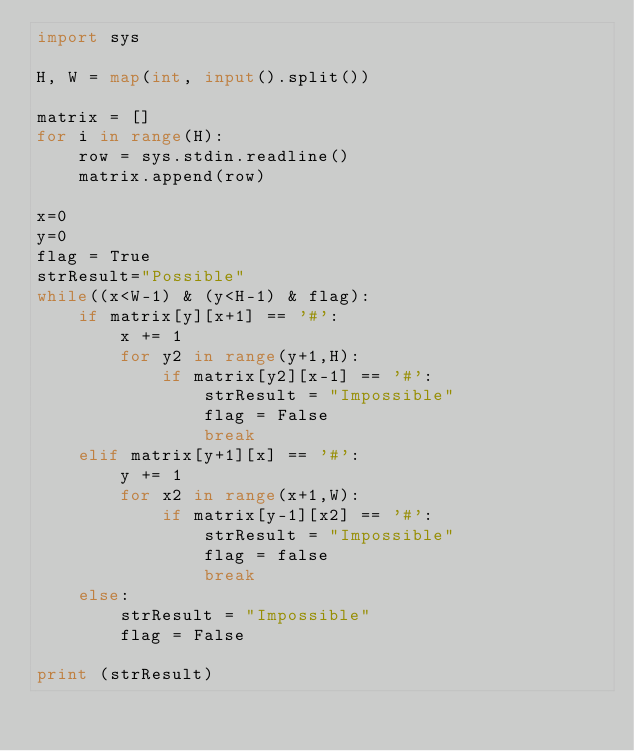Convert code to text. <code><loc_0><loc_0><loc_500><loc_500><_Python_>import sys
 
H, W = map(int, input().split())
 
matrix = []
for i in range(H):
	row = sys.stdin.readline()
	matrix.append(row)
	
x=0
y=0
flag = True
strResult="Possible"
while((x<W-1) & (y<H-1) & flag):
	if matrix[y][x+1] == '#':
		x += 1
		for y2 in range(y+1,H):
			if matrix[y2][x-1] == '#':
				strResult = "Impossible"
				flag = False
				break
	elif matrix[y+1][x] == '#':
		y += 1
		for x2 in range(x+1,W):
			if matrix[y-1][x2] == '#':
				strResult = "Impossible"
				flag = false
				break
	else:
		strResult = "Impossible"
		flag = False
			
print (strResult)</code> 